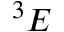<formula> <loc_0><loc_0><loc_500><loc_500>^ { 3 } E</formula> 